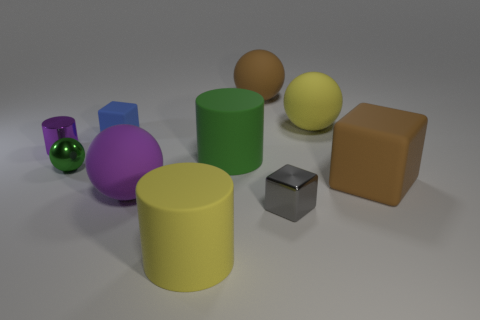There is a yellow thing behind the yellow object that is in front of the blue rubber block; is there a shiny block in front of it?
Your response must be concise. Yes. There is a green matte object that is the same size as the purple rubber sphere; what shape is it?
Your response must be concise. Cylinder. How many small things are red blocks or purple shiny cylinders?
Provide a succinct answer. 1. There is a ball that is made of the same material as the small purple cylinder; what color is it?
Your response must be concise. Green. Is the shape of the brown matte object that is behind the purple cylinder the same as the large yellow rubber thing right of the tiny gray shiny cube?
Your response must be concise. Yes. How many matte objects are either tiny blue things or tiny gray balls?
Provide a short and direct response. 1. There is a object that is the same color as the shiny cylinder; what material is it?
Ensure brevity in your answer.  Rubber. What material is the small cube behind the purple rubber object?
Offer a terse response. Rubber. Is the material of the cylinder that is left of the yellow matte cylinder the same as the gray object?
Offer a very short reply. Yes. How many objects are either purple rubber things or big matte spheres behind the blue rubber cube?
Keep it short and to the point. 3. 